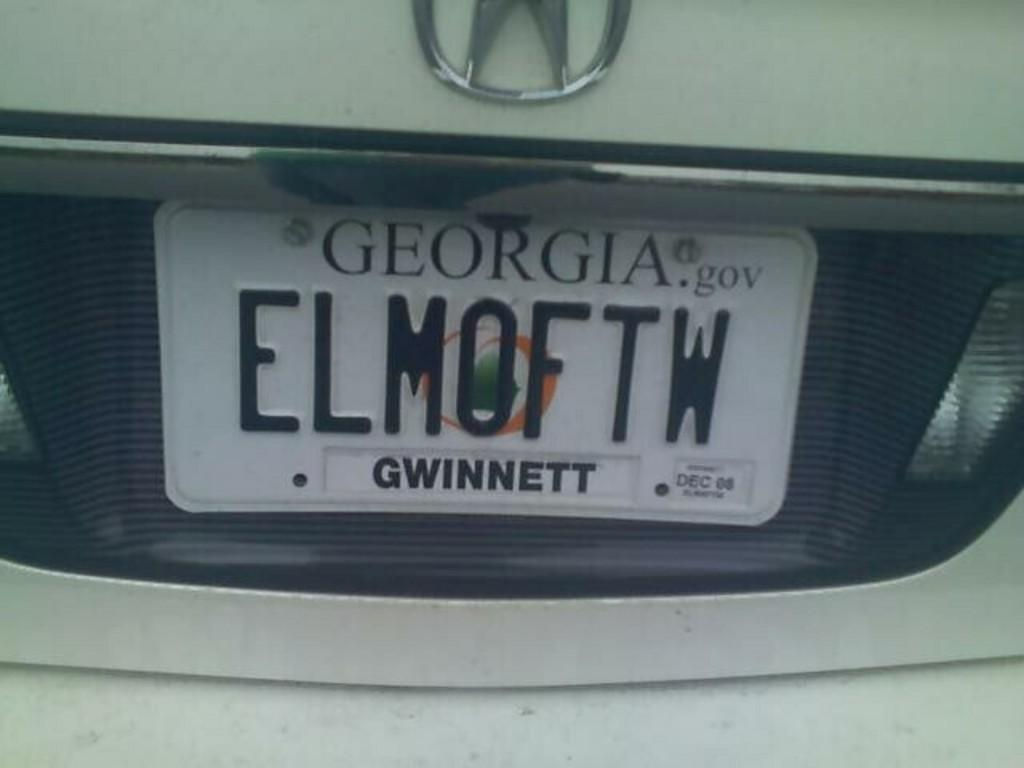<image>
Relay a brief, clear account of the picture shown. White car with license plate that says ELM0FTW. 